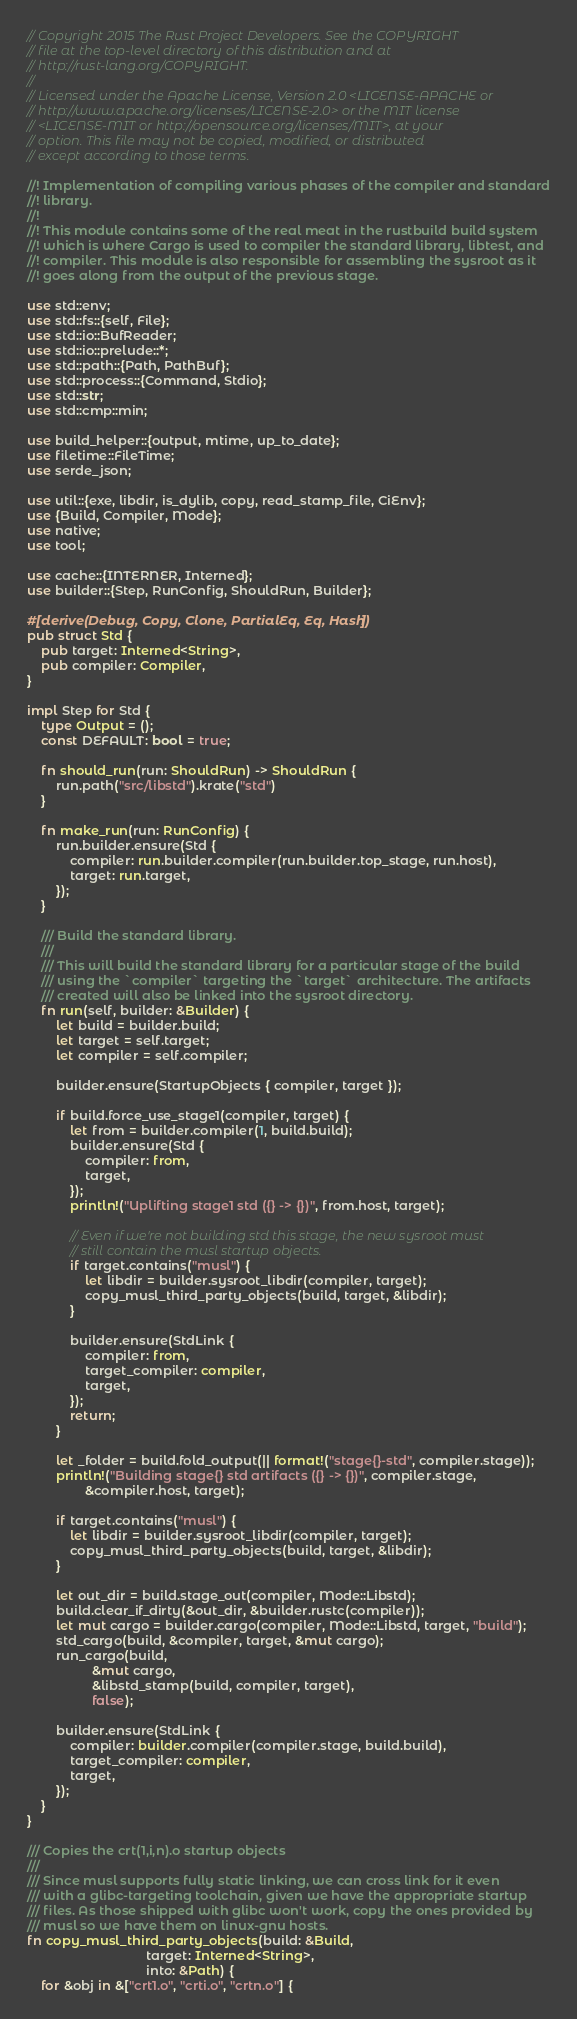<code> <loc_0><loc_0><loc_500><loc_500><_Rust_>// Copyright 2015 The Rust Project Developers. See the COPYRIGHT
// file at the top-level directory of this distribution and at
// http://rust-lang.org/COPYRIGHT.
//
// Licensed under the Apache License, Version 2.0 <LICENSE-APACHE or
// http://www.apache.org/licenses/LICENSE-2.0> or the MIT license
// <LICENSE-MIT or http://opensource.org/licenses/MIT>, at your
// option. This file may not be copied, modified, or distributed
// except according to those terms.

//! Implementation of compiling various phases of the compiler and standard
//! library.
//!
//! This module contains some of the real meat in the rustbuild build system
//! which is where Cargo is used to compiler the standard library, libtest, and
//! compiler. This module is also responsible for assembling the sysroot as it
//! goes along from the output of the previous stage.

use std::env;
use std::fs::{self, File};
use std::io::BufReader;
use std::io::prelude::*;
use std::path::{Path, PathBuf};
use std::process::{Command, Stdio};
use std::str;
use std::cmp::min;

use build_helper::{output, mtime, up_to_date};
use filetime::FileTime;
use serde_json;

use util::{exe, libdir, is_dylib, copy, read_stamp_file, CiEnv};
use {Build, Compiler, Mode};
use native;
use tool;

use cache::{INTERNER, Interned};
use builder::{Step, RunConfig, ShouldRun, Builder};

#[derive(Debug, Copy, Clone, PartialEq, Eq, Hash)]
pub struct Std {
    pub target: Interned<String>,
    pub compiler: Compiler,
}

impl Step for Std {
    type Output = ();
    const DEFAULT: bool = true;

    fn should_run(run: ShouldRun) -> ShouldRun {
        run.path("src/libstd").krate("std")
    }

    fn make_run(run: RunConfig) {
        run.builder.ensure(Std {
            compiler: run.builder.compiler(run.builder.top_stage, run.host),
            target: run.target,
        });
    }

    /// Build the standard library.
    ///
    /// This will build the standard library for a particular stage of the build
    /// using the `compiler` targeting the `target` architecture. The artifacts
    /// created will also be linked into the sysroot directory.
    fn run(self, builder: &Builder) {
        let build = builder.build;
        let target = self.target;
        let compiler = self.compiler;

        builder.ensure(StartupObjects { compiler, target });

        if build.force_use_stage1(compiler, target) {
            let from = builder.compiler(1, build.build);
            builder.ensure(Std {
                compiler: from,
                target,
            });
            println!("Uplifting stage1 std ({} -> {})", from.host, target);

            // Even if we're not building std this stage, the new sysroot must
            // still contain the musl startup objects.
            if target.contains("musl") {
                let libdir = builder.sysroot_libdir(compiler, target);
                copy_musl_third_party_objects(build, target, &libdir);
            }

            builder.ensure(StdLink {
                compiler: from,
                target_compiler: compiler,
                target,
            });
            return;
        }

        let _folder = build.fold_output(|| format!("stage{}-std", compiler.stage));
        println!("Building stage{} std artifacts ({} -> {})", compiler.stage,
                &compiler.host, target);

        if target.contains("musl") {
            let libdir = builder.sysroot_libdir(compiler, target);
            copy_musl_third_party_objects(build, target, &libdir);
        }

        let out_dir = build.stage_out(compiler, Mode::Libstd);
        build.clear_if_dirty(&out_dir, &builder.rustc(compiler));
        let mut cargo = builder.cargo(compiler, Mode::Libstd, target, "build");
        std_cargo(build, &compiler, target, &mut cargo);
        run_cargo(build,
                  &mut cargo,
                  &libstd_stamp(build, compiler, target),
                  false);

        builder.ensure(StdLink {
            compiler: builder.compiler(compiler.stage, build.build),
            target_compiler: compiler,
            target,
        });
    }
}

/// Copies the crt(1,i,n).o startup objects
///
/// Since musl supports fully static linking, we can cross link for it even
/// with a glibc-targeting toolchain, given we have the appropriate startup
/// files. As those shipped with glibc won't work, copy the ones provided by
/// musl so we have them on linux-gnu hosts.
fn copy_musl_third_party_objects(build: &Build,
                                 target: Interned<String>,
                                 into: &Path) {
    for &obj in &["crt1.o", "crti.o", "crtn.o"] {</code> 